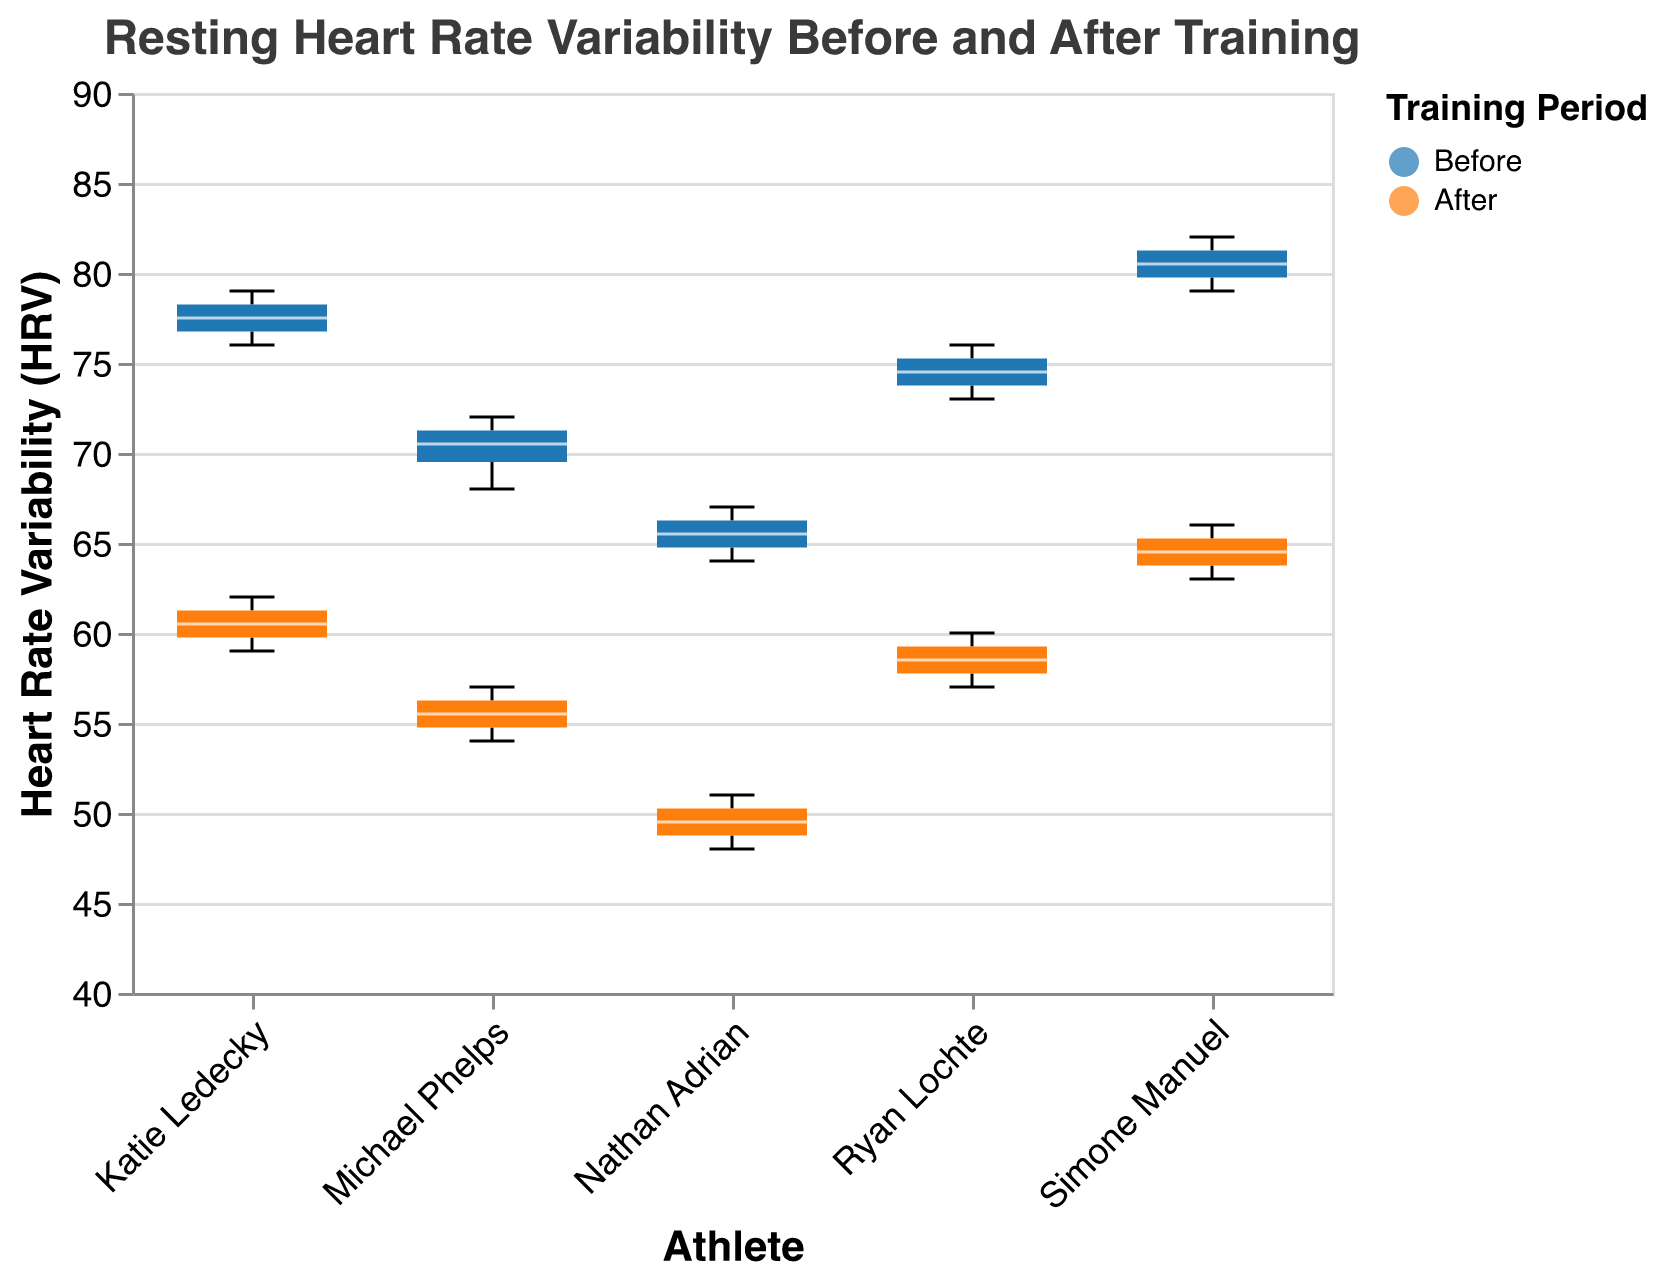What is the title of the figure? The title is typically located at the top of the figure and summarizes the overall content. The title in this figure reads "Resting Heart Rate Variability Before and After Training."
Answer: Resting Heart Rate Variability Before and After Training Which period has the lower median HRV value for Michael Phelps? To find the median HRV value for both periods, look at the central line inside the box for Michael Phelps in "Before" and "After" categories and compare them.
Answer: After Which athlete shows the greatest drop in median HRV from before to after training? Find the median HRV values for each athlete's "Before" and "After" periods and calculate the difference. Simone Manuel's box plot shows the most considerable drop.
Answer: Simone Manuel What is the HRV range for Katie Ledecky before the training? The HRV range is the difference between the maximum and minimum values. For Katie Ledecky before training, this is found by looking at the top and bottom of the "Before" whiskers.
Answer: 78 to 79 Which athlete has the highest HRV before training? Look at the median lines (central lines inside the boxes) for all "Before" periods and identify the highest one.
Answer: Simone Manuel How does Nathan Adrian's HRV variability after training compare to before training? Compare the length of the boxes and whiskers for both "Before" and "After" periods for Nathan Adrian. The "After" box plot is much shorter, indicating less variability.
Answer: Less variability after training Is there any data point in Simone Manuel's 'After' HRV outside the interquartile range (outliers)? Examine Simone Manuel’s "After" box plot. Outliers would be points outside the whiskers extending from the box.
Answer: No Compute the interquartile range (IQR) of HRV for Ryan Lochte after training. IQR is the range between the first quartile (25th percentile) and third quartile (75th percentile). In a box plot, these are the bottom and top of the box. For Ryan Lochte "After," IQR calculation: HRV at Q3 is 60 and at Q1 is 57.
Answer: 3 